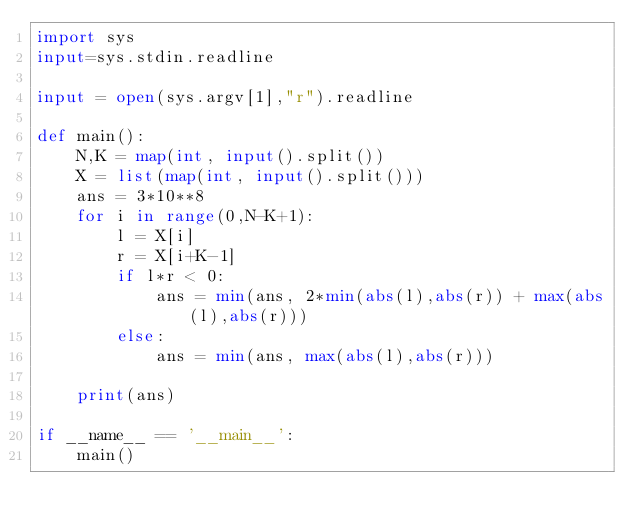Convert code to text. <code><loc_0><loc_0><loc_500><loc_500><_Python_>import sys
input=sys.stdin.readline

input = open(sys.argv[1],"r").readline

def main():
    N,K = map(int, input().split())
    X = list(map(int, input().split()))
    ans = 3*10**8
    for i in range(0,N-K+1):
        l = X[i]
        r = X[i+K-1]
        if l*r < 0:
            ans = min(ans, 2*min(abs(l),abs(r)) + max(abs(l),abs(r)))
        else:
            ans = min(ans, max(abs(l),abs(r)))

    print(ans)

if __name__ == '__main__':
    main()
</code> 